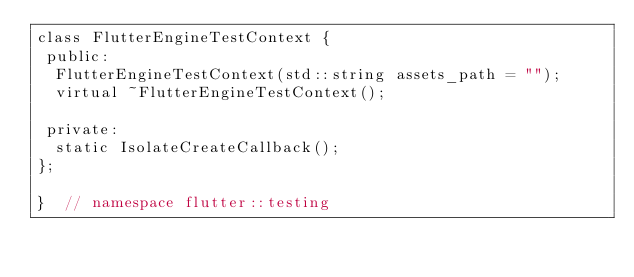<code> <loc_0><loc_0><loc_500><loc_500><_ObjectiveC_>class FlutterEngineTestContext {
 public:
  FlutterEngineTestContext(std::string assets_path = "");
  virtual ~FlutterEngineTestContext();

 private:
  static IsolateCreateCallback();
};

}  // namespace flutter::testing
</code> 